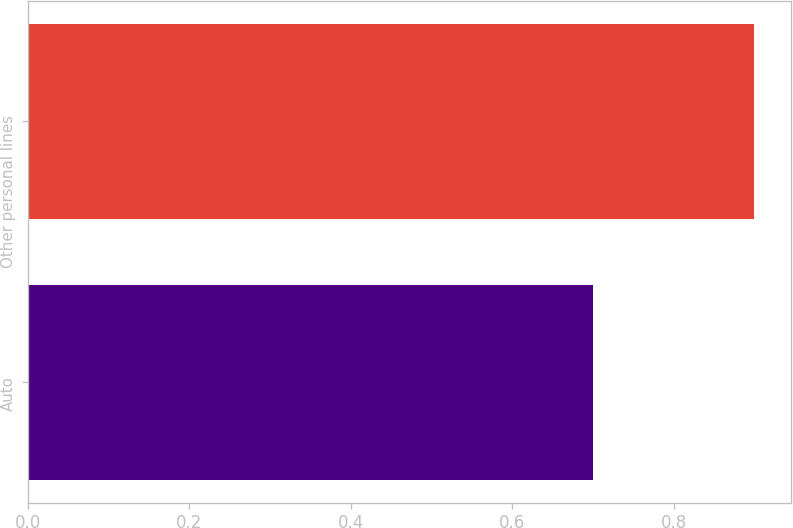Convert chart. <chart><loc_0><loc_0><loc_500><loc_500><bar_chart><fcel>Auto<fcel>Other personal lines<nl><fcel>0.7<fcel>0.9<nl></chart> 